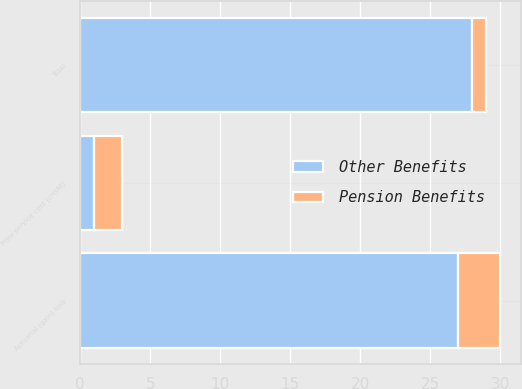<chart> <loc_0><loc_0><loc_500><loc_500><stacked_bar_chart><ecel><fcel>Actuarial (gain) loss<fcel>Prior service cost (credit)<fcel>Total<nl><fcel>Other Benefits<fcel>27<fcel>1<fcel>28<nl><fcel>Pension Benefits<fcel>3<fcel>2<fcel>1<nl></chart> 